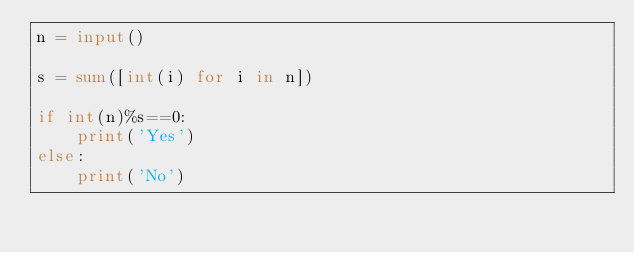<code> <loc_0><loc_0><loc_500><loc_500><_Python_>n = input()

s = sum([int(i) for i in n])

if int(n)%s==0:
    print('Yes')
else:
    print('No')
</code> 